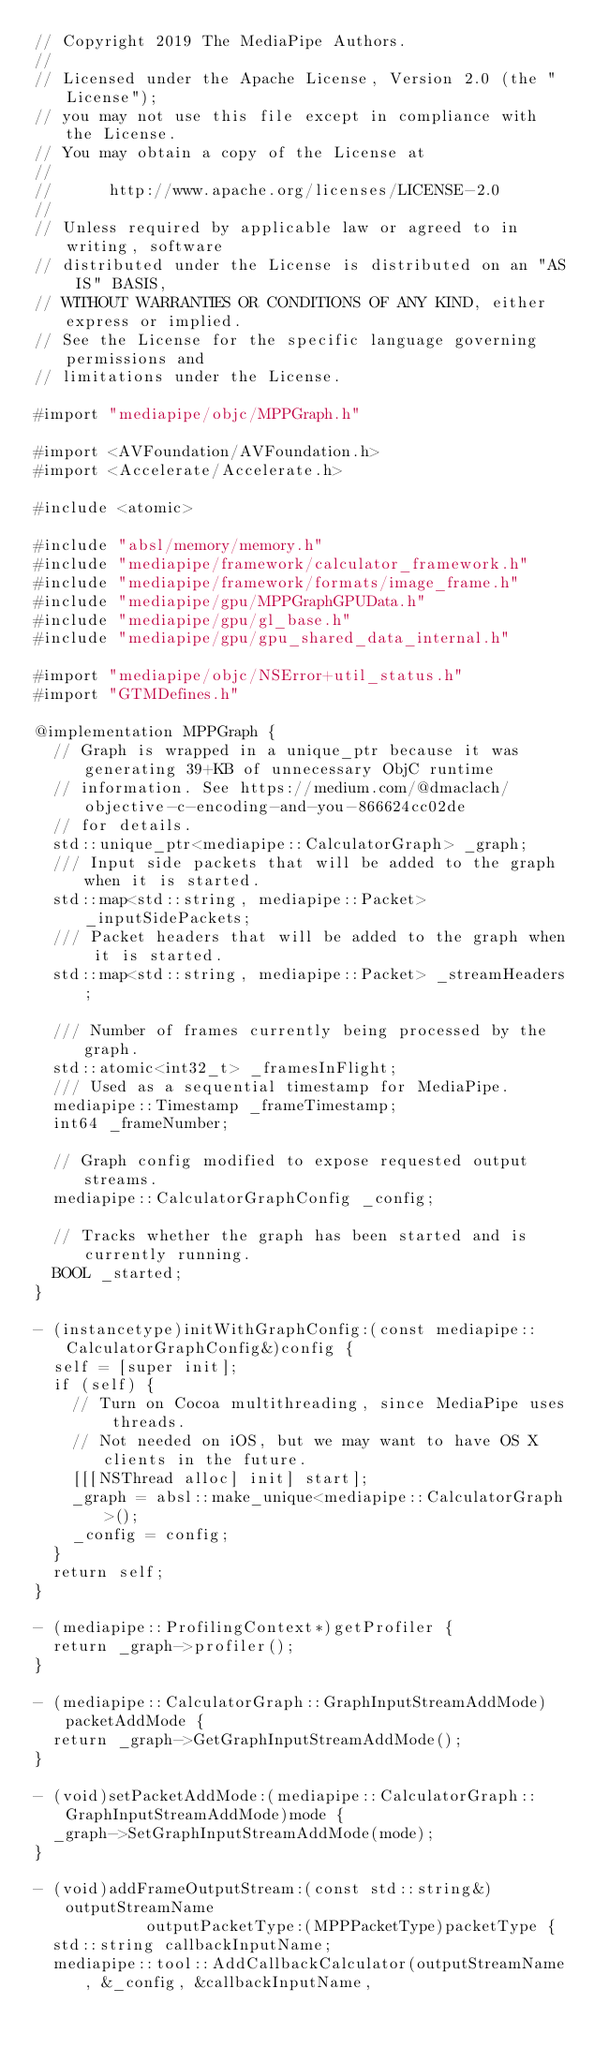Convert code to text. <code><loc_0><loc_0><loc_500><loc_500><_ObjectiveC_>// Copyright 2019 The MediaPipe Authors.
//
// Licensed under the Apache License, Version 2.0 (the "License");
// you may not use this file except in compliance with the License.
// You may obtain a copy of the License at
//
//      http://www.apache.org/licenses/LICENSE-2.0
//
// Unless required by applicable law or agreed to in writing, software
// distributed under the License is distributed on an "AS IS" BASIS,
// WITHOUT WARRANTIES OR CONDITIONS OF ANY KIND, either express or implied.
// See the License for the specific language governing permissions and
// limitations under the License.

#import "mediapipe/objc/MPPGraph.h"

#import <AVFoundation/AVFoundation.h>
#import <Accelerate/Accelerate.h>

#include <atomic>

#include "absl/memory/memory.h"
#include "mediapipe/framework/calculator_framework.h"
#include "mediapipe/framework/formats/image_frame.h"
#include "mediapipe/gpu/MPPGraphGPUData.h"
#include "mediapipe/gpu/gl_base.h"
#include "mediapipe/gpu/gpu_shared_data_internal.h"

#import "mediapipe/objc/NSError+util_status.h"
#import "GTMDefines.h"

@implementation MPPGraph {
  // Graph is wrapped in a unique_ptr because it was generating 39+KB of unnecessary ObjC runtime
  // information. See https://medium.com/@dmaclach/objective-c-encoding-and-you-866624cc02de
  // for details.
  std::unique_ptr<mediapipe::CalculatorGraph> _graph;
  /// Input side packets that will be added to the graph when it is started.
  std::map<std::string, mediapipe::Packet> _inputSidePackets;
  /// Packet headers that will be added to the graph when it is started.
  std::map<std::string, mediapipe::Packet> _streamHeaders;

  /// Number of frames currently being processed by the graph.
  std::atomic<int32_t> _framesInFlight;
  /// Used as a sequential timestamp for MediaPipe.
  mediapipe::Timestamp _frameTimestamp;
  int64 _frameNumber;

  // Graph config modified to expose requested output streams.
  mediapipe::CalculatorGraphConfig _config;

  // Tracks whether the graph has been started and is currently running.
  BOOL _started;
}

- (instancetype)initWithGraphConfig:(const mediapipe::CalculatorGraphConfig&)config {
  self = [super init];
  if (self) {
    // Turn on Cocoa multithreading, since MediaPipe uses threads.
    // Not needed on iOS, but we may want to have OS X clients in the future.
    [[[NSThread alloc] init] start];
    _graph = absl::make_unique<mediapipe::CalculatorGraph>();
    _config = config;
  }
  return self;
}

- (mediapipe::ProfilingContext*)getProfiler {
  return _graph->profiler();
}

- (mediapipe::CalculatorGraph::GraphInputStreamAddMode)packetAddMode {
  return _graph->GetGraphInputStreamAddMode();
}

- (void)setPacketAddMode:(mediapipe::CalculatorGraph::GraphInputStreamAddMode)mode {
  _graph->SetGraphInputStreamAddMode(mode);
}

- (void)addFrameOutputStream:(const std::string&)outputStreamName
            outputPacketType:(MPPPacketType)packetType {
  std::string callbackInputName;
  mediapipe::tool::AddCallbackCalculator(outputStreamName, &_config, &callbackInputName,</code> 